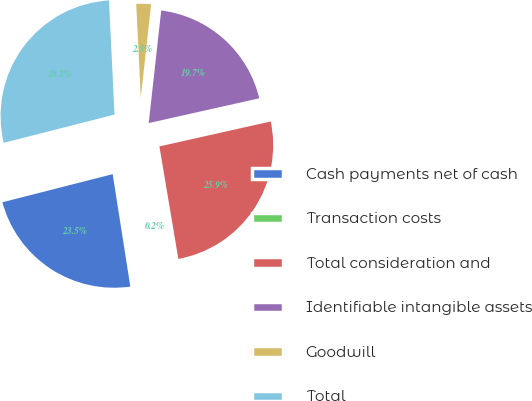Convert chart. <chart><loc_0><loc_0><loc_500><loc_500><pie_chart><fcel>Cash payments net of cash<fcel>Transaction costs<fcel>Total consideration and<fcel>Identifiable intangible assets<fcel>Goodwill<fcel>Total<nl><fcel>23.5%<fcel>0.18%<fcel>25.85%<fcel>19.73%<fcel>2.53%<fcel>28.2%<nl></chart> 